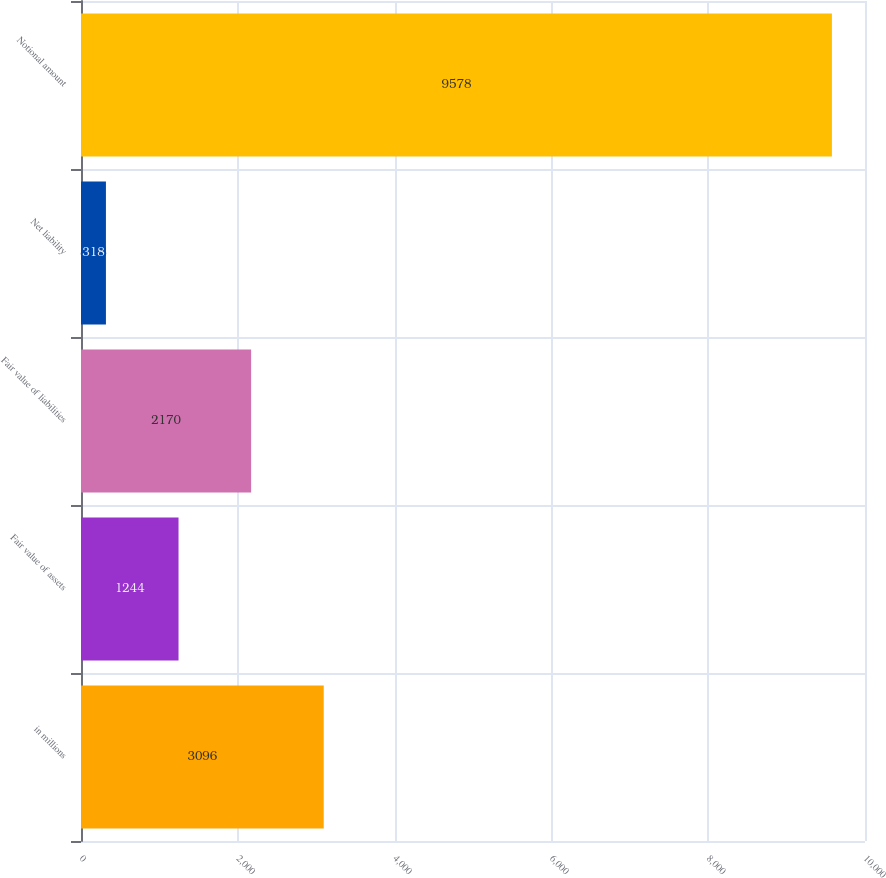<chart> <loc_0><loc_0><loc_500><loc_500><bar_chart><fcel>in millions<fcel>Fair value of assets<fcel>Fair value of liabilities<fcel>Net liability<fcel>Notional amount<nl><fcel>3096<fcel>1244<fcel>2170<fcel>318<fcel>9578<nl></chart> 